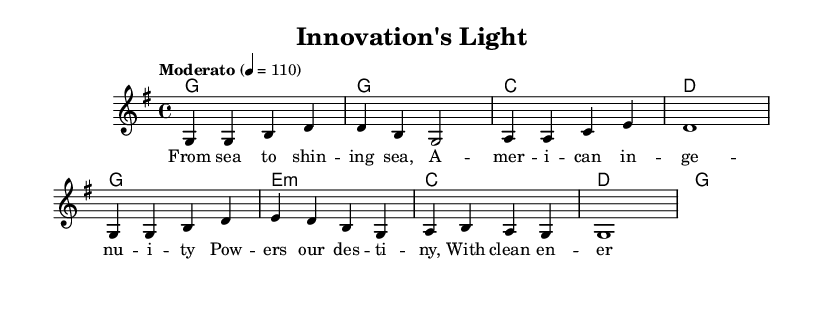What is the key signature of this music? The key signature is G major, which has one sharp (F#). This can be determined from the \key command in the code: \key g \major.
Answer: G major What is the time signature of this music? The time signature is 4/4, indicating four beats per measure. This is specified in the code with the \time command: \time 4/4.
Answer: 4/4 What is the tempo marking provided in the sheet music? The tempo marking is "Moderato", which indicates a moderate pace for the piece. This is found in the tempo command: \tempo "Moderato" 4 = 110, indicating a specific metronome marking as well.
Answer: Moderato How many measures are there in the melody section? There are eight measures in the melody section. This can be counted by looking at the melody notation and the structure of the notes divided into bars.
Answer: Eight What is the first note of the melody? The first note of the melody is G. This is found at the very beginning of the melody section notated with the note g4.
Answer: G Which chord is played at the beginning of the harmonies? The first chord played is G major. This can be established by looking at the first chord in the harmonies section, where it is denoted as g1.
Answer: G 